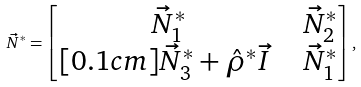<formula> <loc_0><loc_0><loc_500><loc_500>\vec { N } ^ { * } = \begin{bmatrix} \vec { N } ^ { * } _ { 1 } \ & \vec { N } ^ { * } _ { 2 } \\ [ 0 . 1 c m ] \vec { N } ^ { * } _ { 3 } + \hat { \rho } ^ { * } \vec { I } \ \ & { \vec { N } ^ { * } _ { 1 } } \end{bmatrix} ,</formula> 